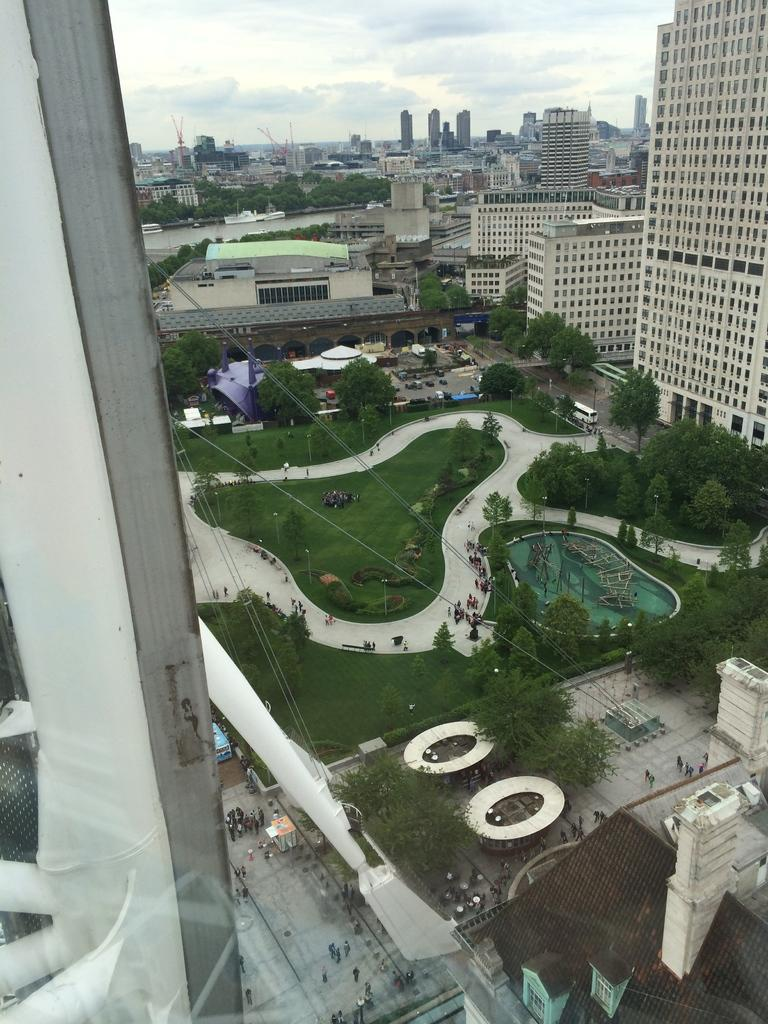What type of structures can be seen in the image? There are buildings in the image. What natural elements are present in the image? There are trees in the image. What are the people in the image doing? The people are on the ground in the image. What can be seen in the background of the image? The sky is visible in the background of the image. Are there any arches visible in the image? There is no mention of arches in the provided facts, so we cannot determine if any are present in the image. Can you see any icicles hanging from the trees in the image? There is no mention of icicles in the provided facts, so we cannot determine if any are present in the image. 